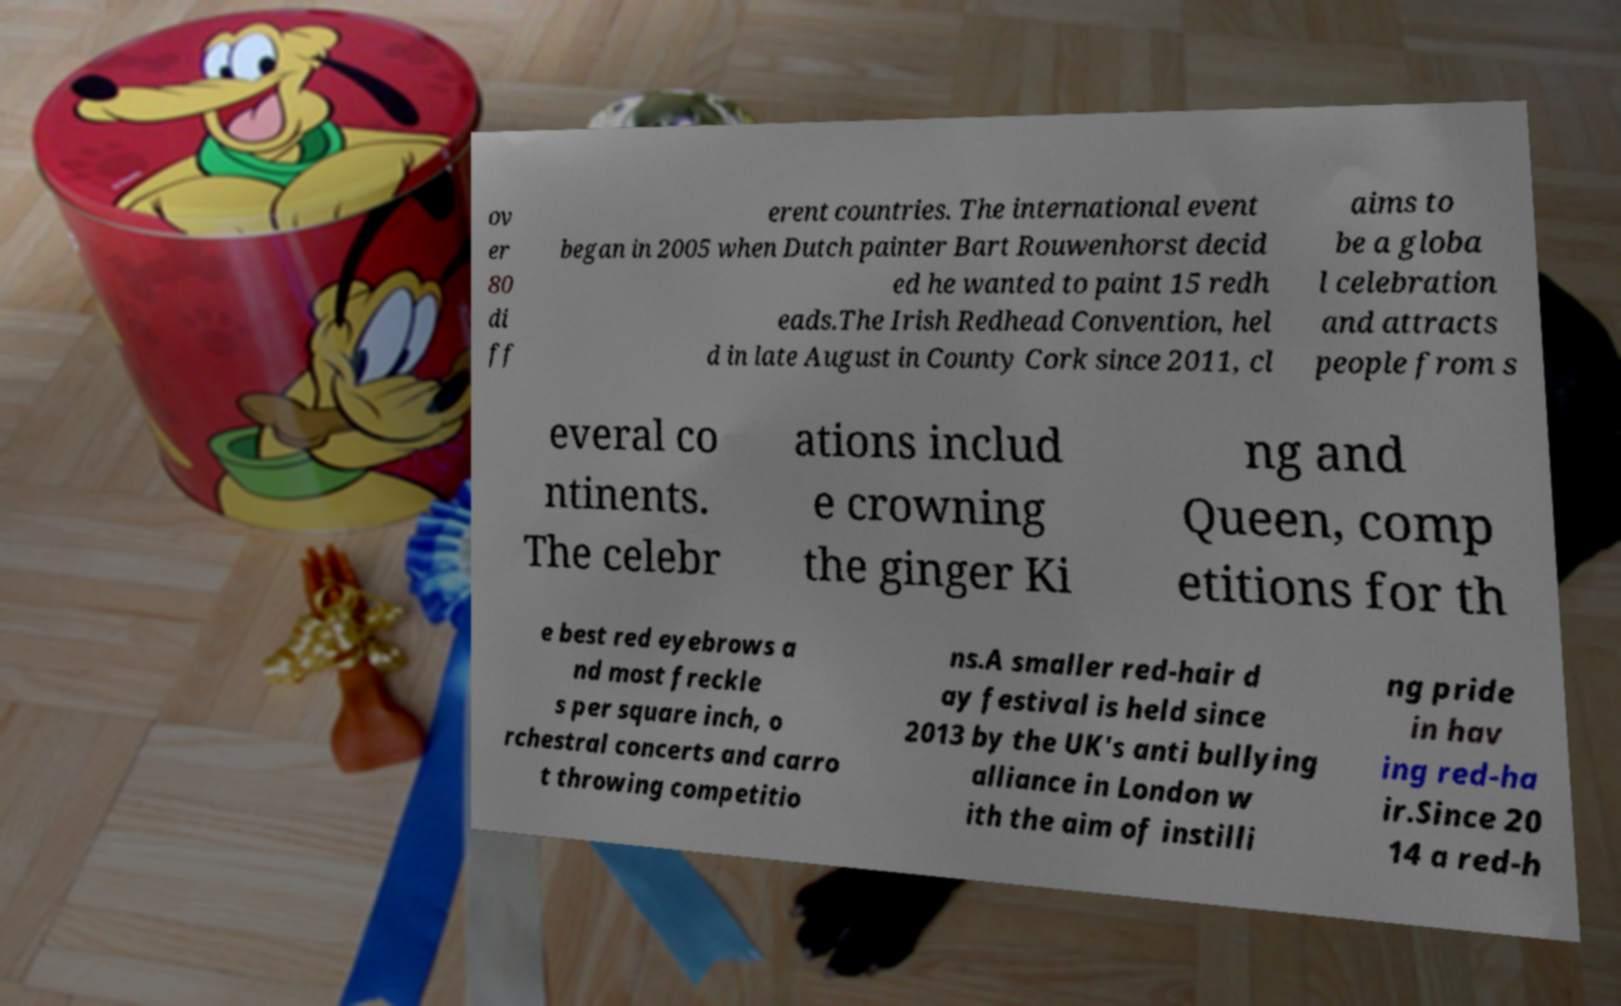Please read and relay the text visible in this image. What does it say? ov er 80 di ff erent countries. The international event began in 2005 when Dutch painter Bart Rouwenhorst decid ed he wanted to paint 15 redh eads.The Irish Redhead Convention, hel d in late August in County Cork since 2011, cl aims to be a globa l celebration and attracts people from s everal co ntinents. The celebr ations includ e crowning the ginger Ki ng and Queen, comp etitions for th e best red eyebrows a nd most freckle s per square inch, o rchestral concerts and carro t throwing competitio ns.A smaller red-hair d ay festival is held since 2013 by the UK's anti bullying alliance in London w ith the aim of instilli ng pride in hav ing red-ha ir.Since 20 14 a red-h 